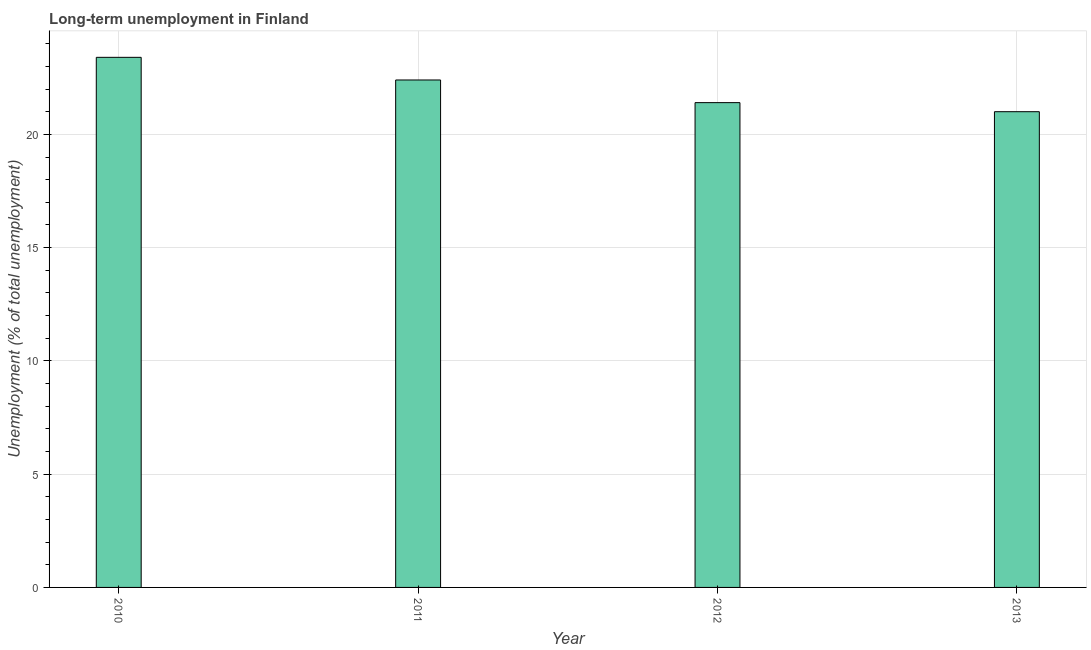Does the graph contain any zero values?
Your answer should be very brief. No. Does the graph contain grids?
Give a very brief answer. Yes. What is the title of the graph?
Make the answer very short. Long-term unemployment in Finland. What is the label or title of the X-axis?
Keep it short and to the point. Year. What is the label or title of the Y-axis?
Make the answer very short. Unemployment (% of total unemployment). What is the long-term unemployment in 2012?
Keep it short and to the point. 21.4. Across all years, what is the maximum long-term unemployment?
Your answer should be very brief. 23.4. In which year was the long-term unemployment minimum?
Keep it short and to the point. 2013. What is the sum of the long-term unemployment?
Keep it short and to the point. 88.2. What is the average long-term unemployment per year?
Offer a terse response. 22.05. What is the median long-term unemployment?
Provide a succinct answer. 21.9. Do a majority of the years between 2011 and 2012 (inclusive) have long-term unemployment greater than 7 %?
Provide a short and direct response. Yes. What is the ratio of the long-term unemployment in 2010 to that in 2011?
Offer a terse response. 1.04. Is the long-term unemployment in 2011 less than that in 2013?
Keep it short and to the point. No. Is the difference between the long-term unemployment in 2012 and 2013 greater than the difference between any two years?
Your response must be concise. No. What is the difference between the highest and the second highest long-term unemployment?
Provide a short and direct response. 1. Is the sum of the long-term unemployment in 2010 and 2013 greater than the maximum long-term unemployment across all years?
Offer a terse response. Yes. What is the difference between the highest and the lowest long-term unemployment?
Offer a terse response. 2.4. In how many years, is the long-term unemployment greater than the average long-term unemployment taken over all years?
Provide a short and direct response. 2. How many bars are there?
Keep it short and to the point. 4. Are all the bars in the graph horizontal?
Ensure brevity in your answer.  No. What is the difference between two consecutive major ticks on the Y-axis?
Your answer should be compact. 5. Are the values on the major ticks of Y-axis written in scientific E-notation?
Provide a succinct answer. No. What is the Unemployment (% of total unemployment) in 2010?
Give a very brief answer. 23.4. What is the Unemployment (% of total unemployment) of 2011?
Give a very brief answer. 22.4. What is the Unemployment (% of total unemployment) of 2012?
Provide a succinct answer. 21.4. What is the difference between the Unemployment (% of total unemployment) in 2010 and 2011?
Keep it short and to the point. 1. What is the difference between the Unemployment (% of total unemployment) in 2010 and 2013?
Provide a short and direct response. 2.4. What is the difference between the Unemployment (% of total unemployment) in 2011 and 2012?
Your answer should be compact. 1. What is the difference between the Unemployment (% of total unemployment) in 2011 and 2013?
Your answer should be compact. 1.4. What is the difference between the Unemployment (% of total unemployment) in 2012 and 2013?
Keep it short and to the point. 0.4. What is the ratio of the Unemployment (% of total unemployment) in 2010 to that in 2011?
Keep it short and to the point. 1.04. What is the ratio of the Unemployment (% of total unemployment) in 2010 to that in 2012?
Provide a succinct answer. 1.09. What is the ratio of the Unemployment (% of total unemployment) in 2010 to that in 2013?
Provide a succinct answer. 1.11. What is the ratio of the Unemployment (% of total unemployment) in 2011 to that in 2012?
Make the answer very short. 1.05. What is the ratio of the Unemployment (% of total unemployment) in 2011 to that in 2013?
Provide a short and direct response. 1.07. What is the ratio of the Unemployment (% of total unemployment) in 2012 to that in 2013?
Offer a very short reply. 1.02. 